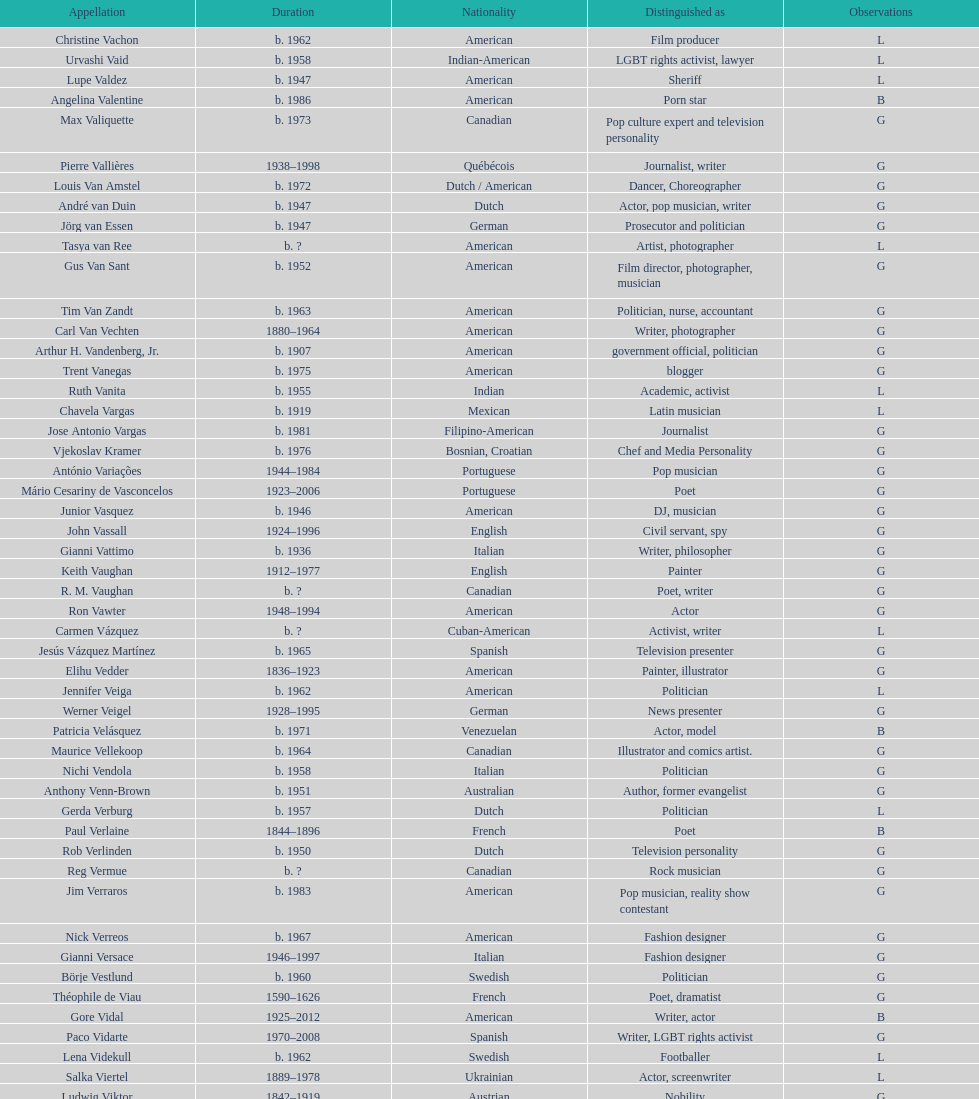Which is the previous name from lupe valdez Urvashi Vaid. 